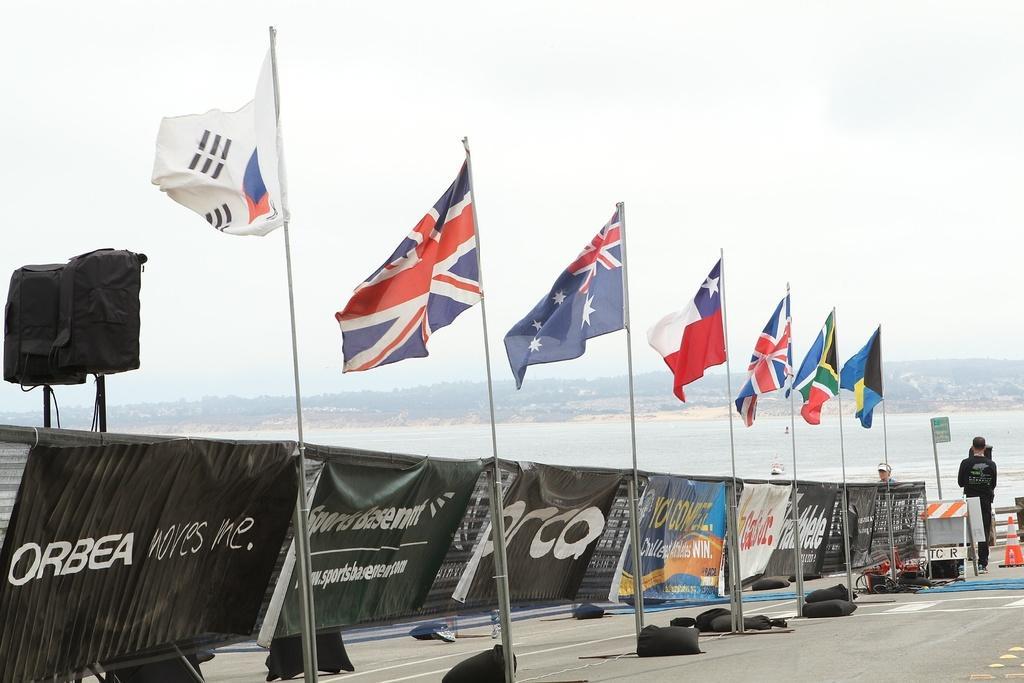Please provide a concise description of this image. Here in this picture we can see number of flag posts present on the road and beside it we can see number of banners hanging over a place and we can also see speakers present and in the far we can see a person standing and in front of him we can see water present all over the place and we can see the sky is cloudy. 